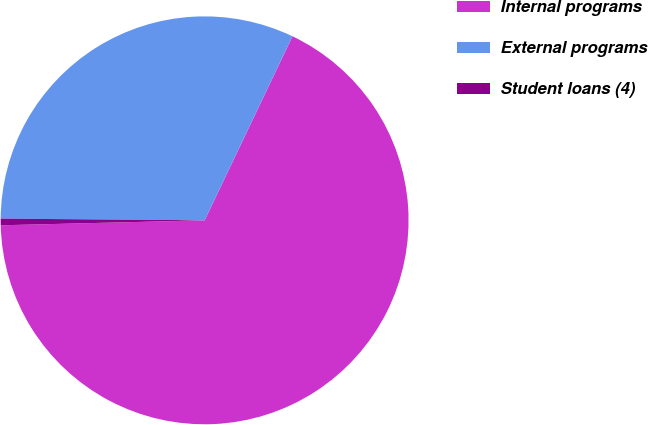<chart> <loc_0><loc_0><loc_500><loc_500><pie_chart><fcel>Internal programs<fcel>External programs<fcel>Student loans (4)<nl><fcel>67.53%<fcel>31.96%<fcel>0.52%<nl></chart> 